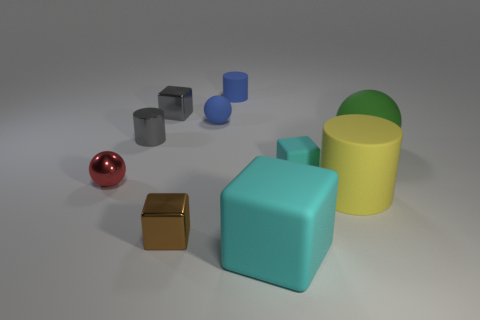The yellow object that is made of the same material as the green ball is what size?
Offer a terse response. Large. What material is the cyan object that is the same size as the red thing?
Ensure brevity in your answer.  Rubber. Do the matte sphere that is to the left of the big rubber sphere and the rubber sphere that is to the right of the tiny rubber ball have the same size?
Your answer should be compact. No. What number of things are yellow matte cylinders or large rubber objects in front of the small cyan object?
Provide a succinct answer. 2. Are there any large cyan matte things that have the same shape as the brown metallic thing?
Your response must be concise. Yes. How big is the metallic block that is behind the small sphere left of the brown metal object?
Ensure brevity in your answer.  Small. Does the tiny rubber ball have the same color as the small matte cylinder?
Offer a terse response. Yes. What number of shiny things are small cyan things or small brown cubes?
Provide a succinct answer. 1. What number of purple rubber objects are there?
Offer a very short reply. 0. Are the red sphere in front of the metallic cylinder and the small block behind the large green rubber object made of the same material?
Ensure brevity in your answer.  Yes. 